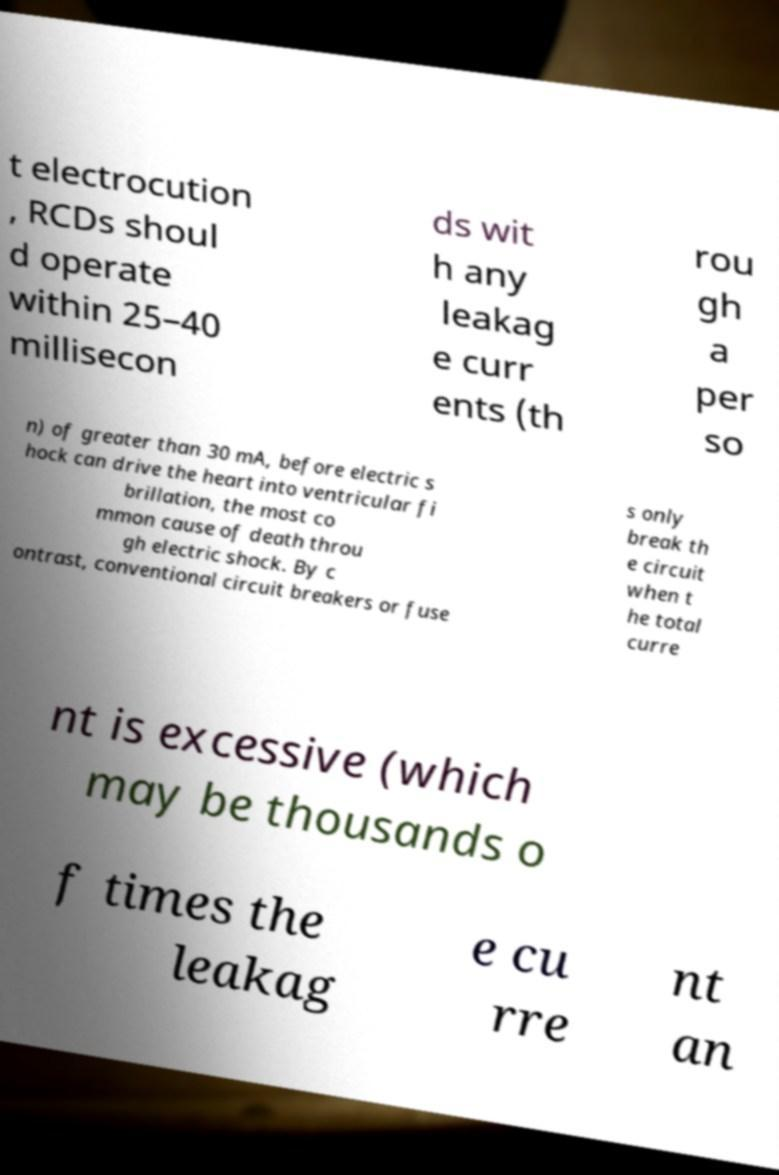Can you read and provide the text displayed in the image?This photo seems to have some interesting text. Can you extract and type it out for me? t electrocution , RCDs shoul d operate within 25–40 millisecon ds wit h any leakag e curr ents (th rou gh a per so n) of greater than 30 mA, before electric s hock can drive the heart into ventricular fi brillation, the most co mmon cause of death throu gh electric shock. By c ontrast, conventional circuit breakers or fuse s only break th e circuit when t he total curre nt is excessive (which may be thousands o f times the leakag e cu rre nt an 